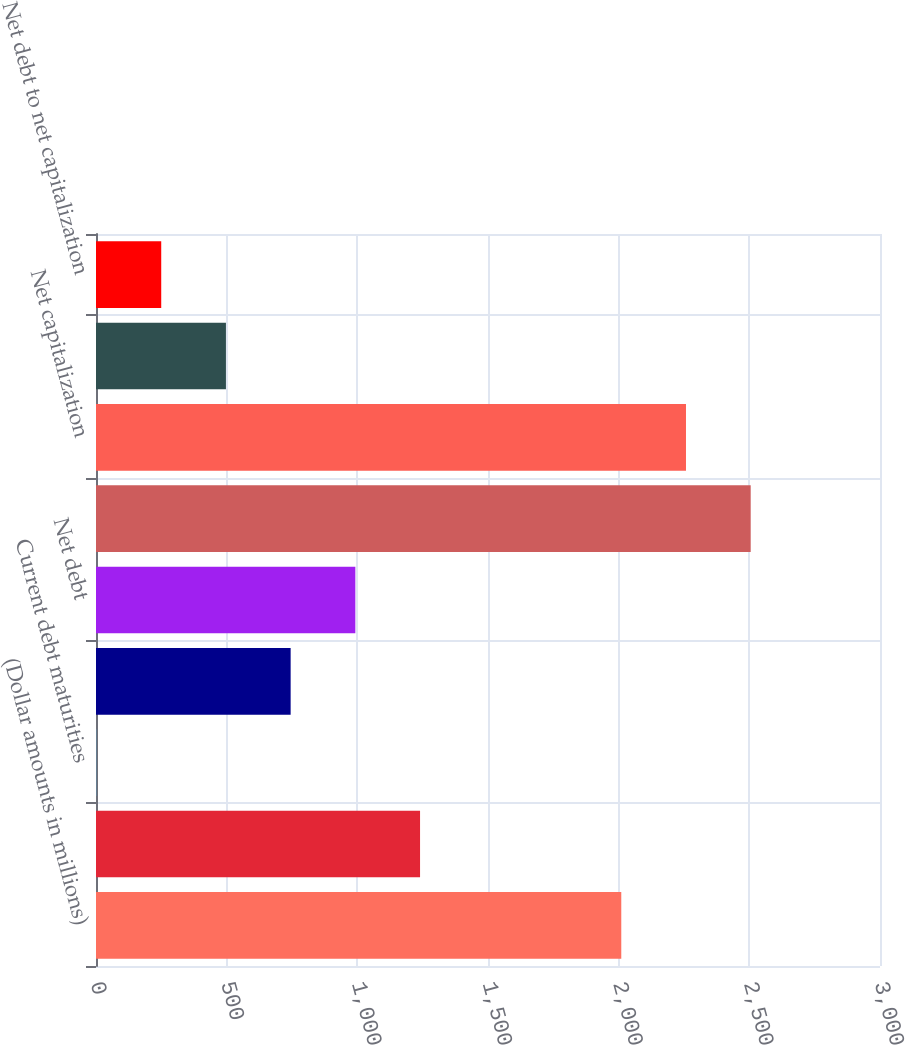Convert chart to OTSL. <chart><loc_0><loc_0><loc_500><loc_500><bar_chart><fcel>(Dollar amounts in millions)<fcel>Long-term debt<fcel>Current debt maturities<fcel>Cash and cash equivalents<fcel>Net debt<fcel>Total capitalization<fcel>Net capitalization<fcel>Long-term debt to total<fcel>Net debt to net capitalization<nl><fcel>2010<fcel>1240<fcel>2<fcel>744.8<fcel>992.4<fcel>2505.2<fcel>2257.6<fcel>497.2<fcel>249.6<nl></chart> 